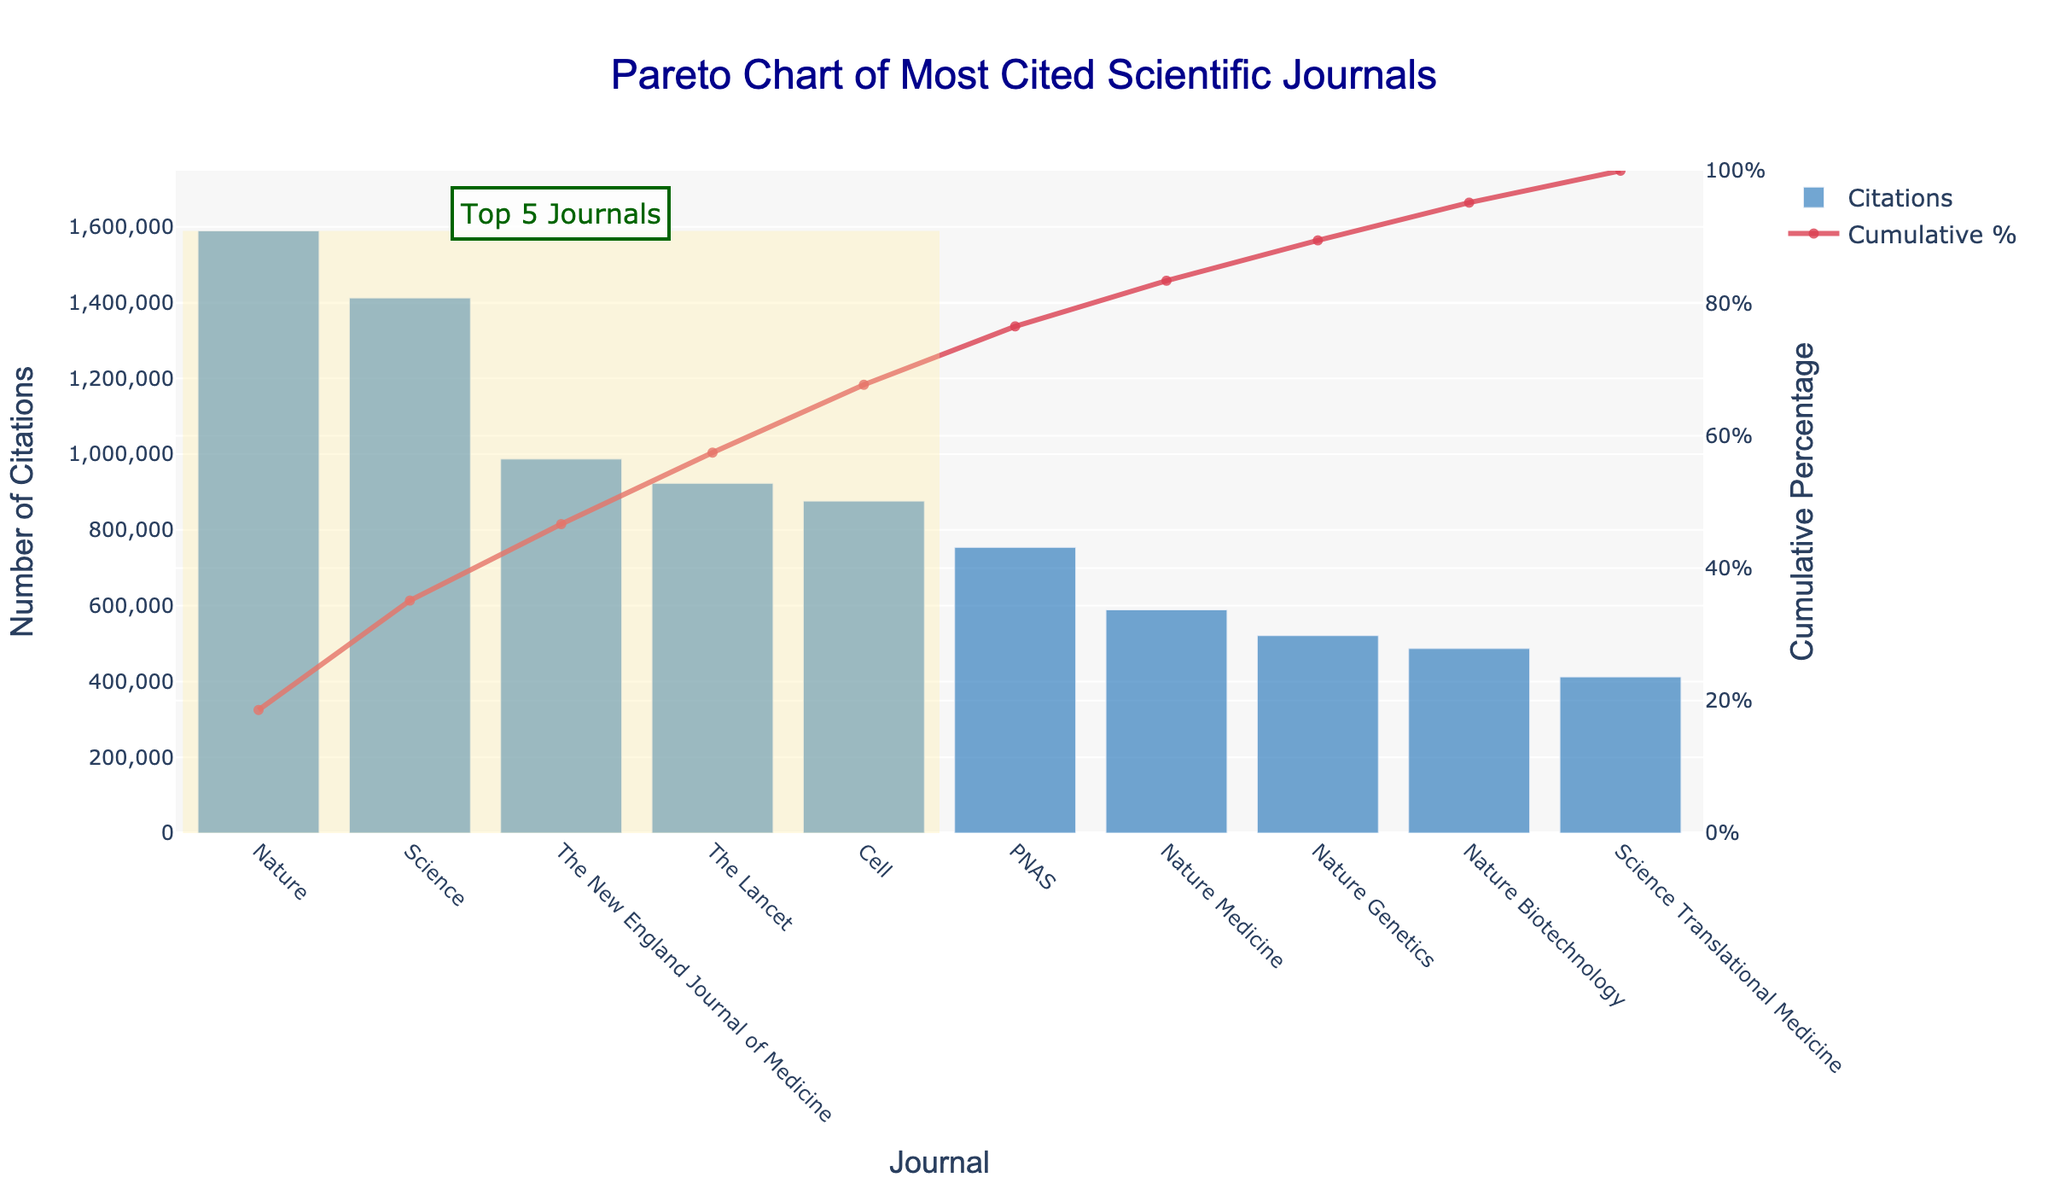What is the title of the chart? The title of the chart is typically displayed at the top. Here, it is shown in dark blue and reads "Pareto Chart of Most Cited Scientific Journals".
Answer: Pareto Chart of Most Cited Scientific Journals Which journal has the highest number of citations? In the bar section, the journal with the tallest bar represents the highest number of citations. Here, "Nature" has the tallest bar.
Answer: Nature What is the impact factor of the journal 'Science'? While the chart does not directly show the impact factor, we know from the provided dataset that "Science" has an impact factor of 47.728.
Answer: 47.728 How many journals have more than 1,000,000 citations? The bars representing journals with citations greater than 1,000,000 are "Nature" with 1,589,000 citations and "Science" with 1,412,000 citations. Two journals fall into this category.
Answer: Two What percentage of cumulative citations does the journal 'PNAS' account for? To find this, identify the cumulative percentage for 'PNAS', which is displayed with the scatter line at the corresponding journal's position. 'PNAS' shows roughly 80% cumulative percentage.
Answer: About 80% Which journal has the lowest cumulative percentage shown up to its citations? By looking at the cumulative percentage scatter points, "Nature Biotechnology" has the lowest percentage while still on the graph.
Answer: Nature Biotechnology How many journals are highlighted as 'Top 5 Journals'? The shaded rectangle area only encompasses the top five journals based on their citation counts. These are highlighted visually.
Answer: Five What fraction of total citations do the top 3 journals contribute to? Adding the citation counts for 'Nature', 'Science', and 'The New England Journal of Medicine' results in 1,589,000 + 1,412,000 + 987,000 = 3,988,000. Then, divide this by the total citations of all journals (1,589,000 + 1,412,000 + 987,000 + 923,000 + 876,000 + 754,000 + 589,000 + 521,000 + 487,000 + 412,000 = 8,550,000). Therefore, the fraction is 3,988,000 / 8,550,000.
Answer: About 0.467 Is 'Cell' ranked higher or lower than 'The Lancet' in terms of citations? By comparing the heights of the bars, 'The Lancet' is taller than 'Cell', indicating 'The Lancet' has more citations. Therefore, 'Cell' is ranked lower.
Answer: Lower What is the cumulative percentage when considering 'Nature', 'Science', and 'The New England Journal of Medicine'? Sum the citations of these journals (1,589,000 + 1,412,000 + 987,000) and divide by the total citations, then multiply by 100. (3,988,000 / 8,550,000) * 100 ≈ 46.67%.
Answer: About 46.67% 